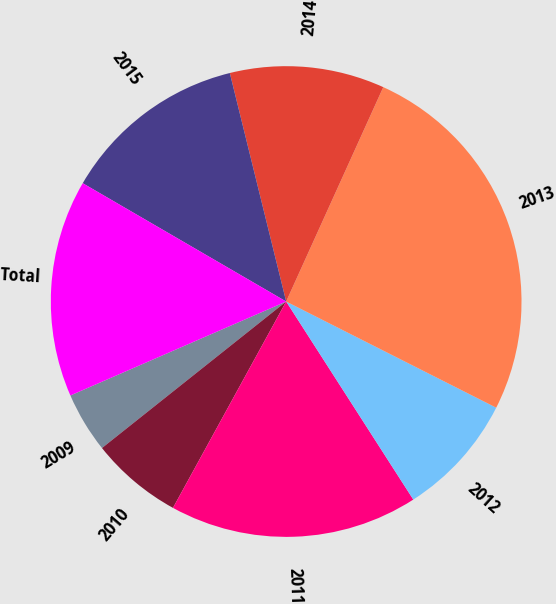<chart> <loc_0><loc_0><loc_500><loc_500><pie_chart><fcel>2009<fcel>2010<fcel>2011<fcel>2012<fcel>2013<fcel>2014<fcel>2015<fcel>Total<nl><fcel>4.16%<fcel>6.32%<fcel>17.07%<fcel>8.47%<fcel>25.68%<fcel>10.62%<fcel>12.77%<fcel>14.92%<nl></chart> 